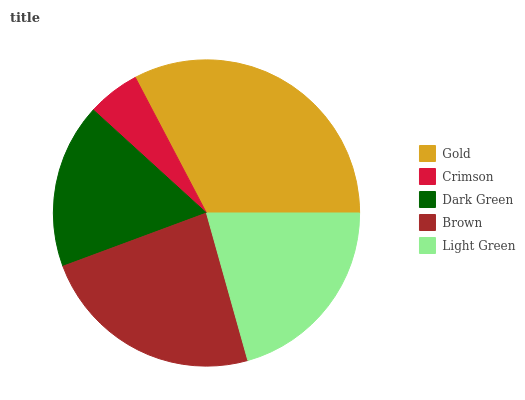Is Crimson the minimum?
Answer yes or no. Yes. Is Gold the maximum?
Answer yes or no. Yes. Is Dark Green the minimum?
Answer yes or no. No. Is Dark Green the maximum?
Answer yes or no. No. Is Dark Green greater than Crimson?
Answer yes or no. Yes. Is Crimson less than Dark Green?
Answer yes or no. Yes. Is Crimson greater than Dark Green?
Answer yes or no. No. Is Dark Green less than Crimson?
Answer yes or no. No. Is Light Green the high median?
Answer yes or no. Yes. Is Light Green the low median?
Answer yes or no. Yes. Is Crimson the high median?
Answer yes or no. No. Is Brown the low median?
Answer yes or no. No. 